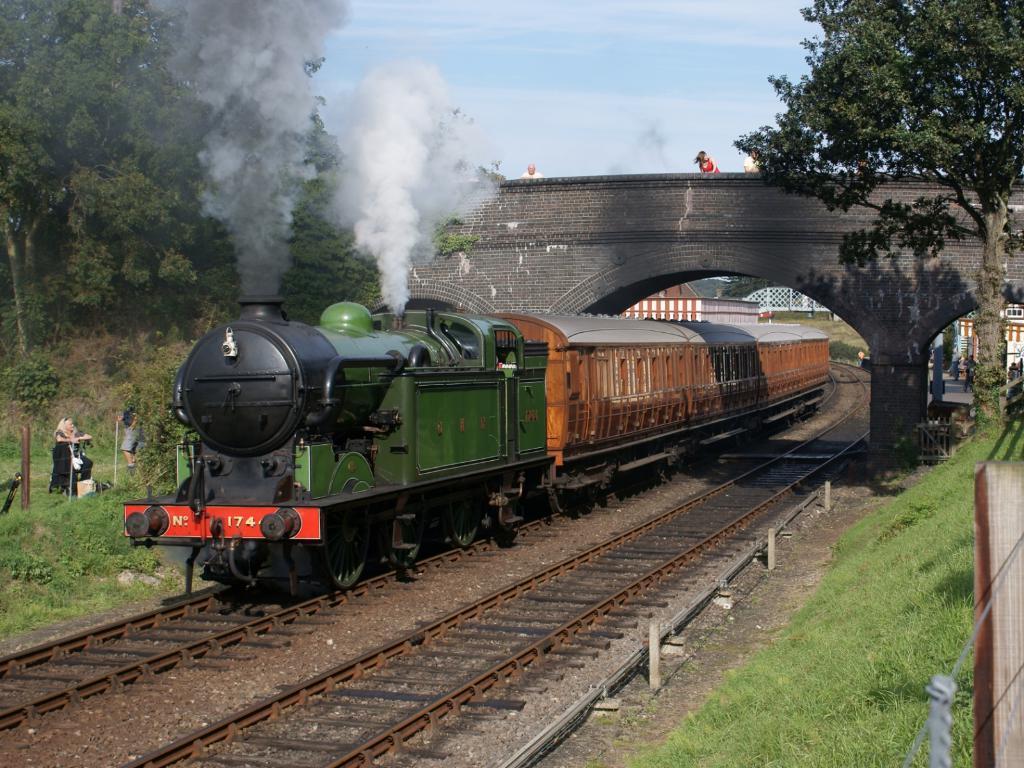How would you summarize this image in a sentence or two? In this image I can see a train on the railway track. I can see a bridge,truss,smoke,fencing. The sky is in blue and white color. 